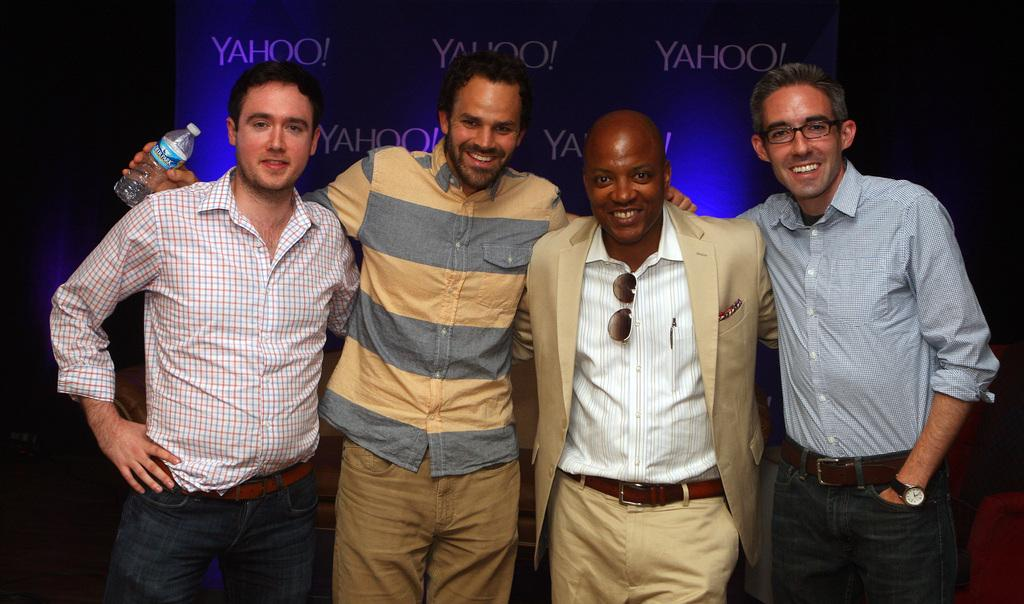What are the people in the image doing? The people in the image are standing. Can you describe any specific actions or interactions among the people? One person is holding an object. Are there any accessories or items that some people are wearing? Some people are wearing glasses. What can be seen in the background of the image? There is a screen in the background of the image. What type of behavior is the daughter exhibiting in the image? There is no mention of a daughter or any specific behavior in the image. 